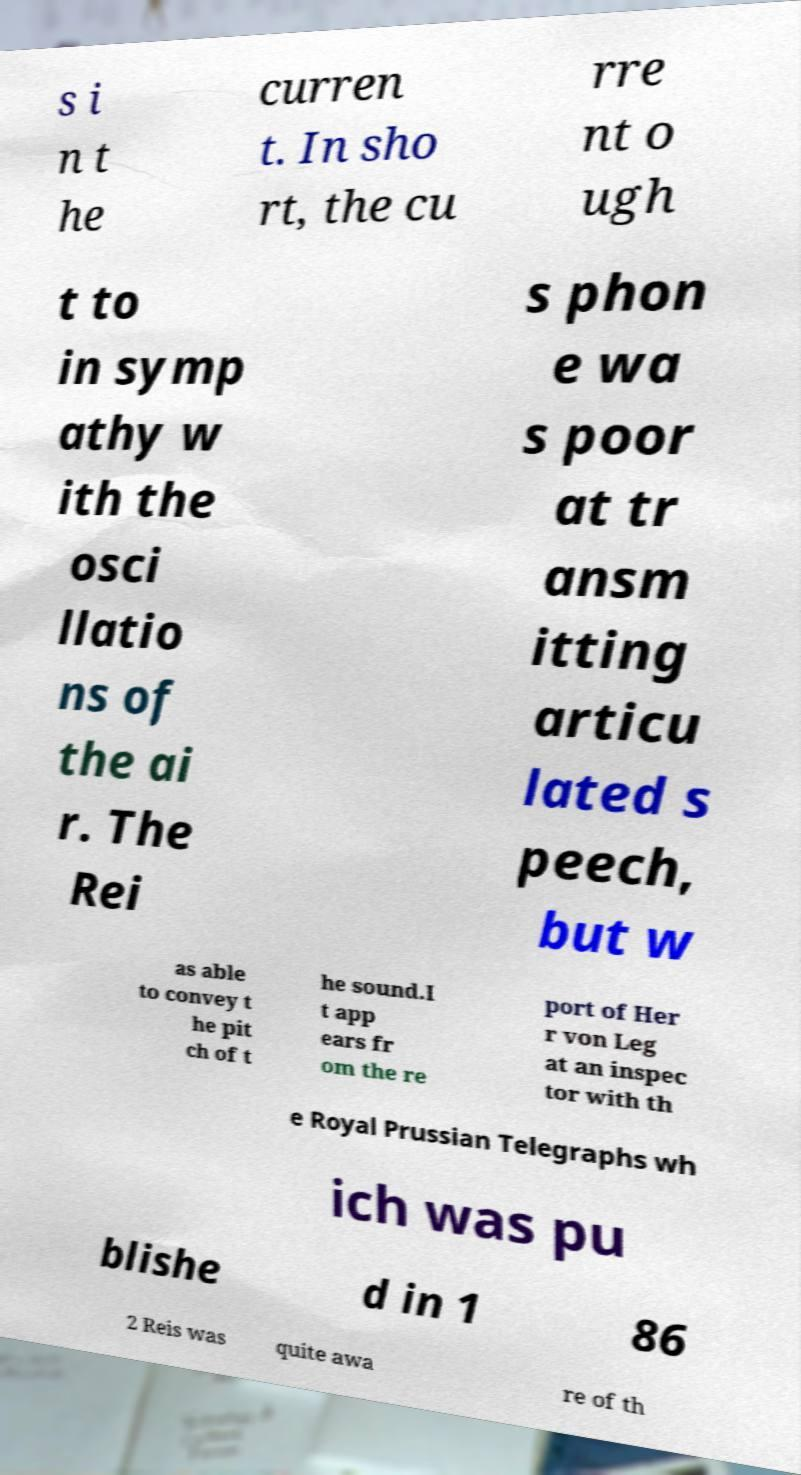Could you extract and type out the text from this image? s i n t he curren t. In sho rt, the cu rre nt o ugh t to in symp athy w ith the osci llatio ns of the ai r. The Rei s phon e wa s poor at tr ansm itting articu lated s peech, but w as able to convey t he pit ch of t he sound.I t app ears fr om the re port of Her r von Leg at an inspec tor with th e Royal Prussian Telegraphs wh ich was pu blishe d in 1 86 2 Reis was quite awa re of th 